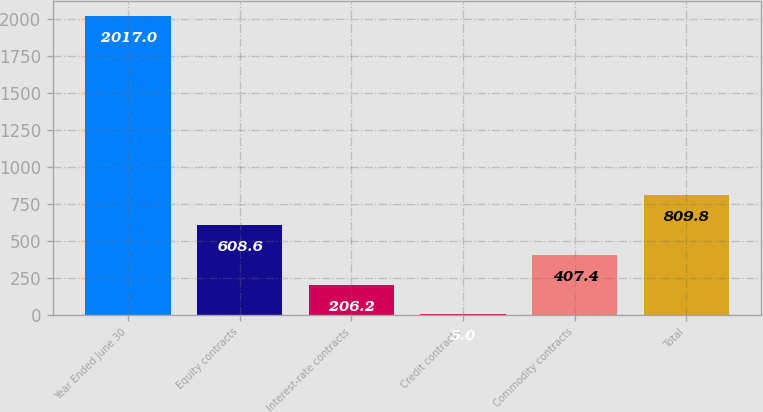<chart> <loc_0><loc_0><loc_500><loc_500><bar_chart><fcel>Year Ended June 30<fcel>Equity contracts<fcel>Interest-rate contracts<fcel>Credit contracts<fcel>Commodity contracts<fcel>Total<nl><fcel>2017<fcel>608.6<fcel>206.2<fcel>5<fcel>407.4<fcel>809.8<nl></chart> 